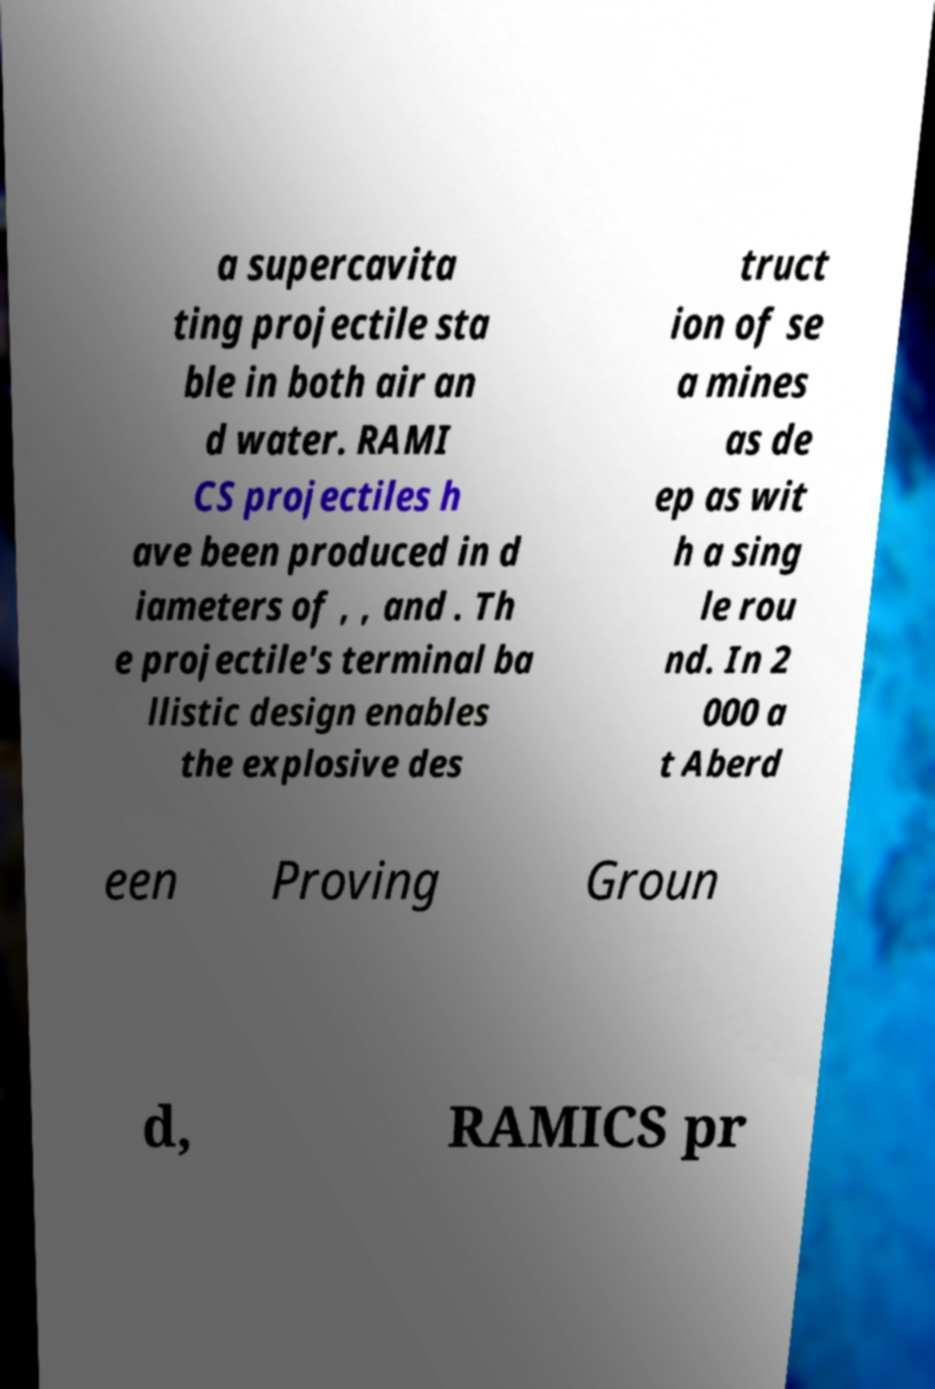Could you extract and type out the text from this image? a supercavita ting projectile sta ble in both air an d water. RAMI CS projectiles h ave been produced in d iameters of , , and . Th e projectile's terminal ba llistic design enables the explosive des truct ion of se a mines as de ep as wit h a sing le rou nd. In 2 000 a t Aberd een Proving Groun d, RAMICS pr 